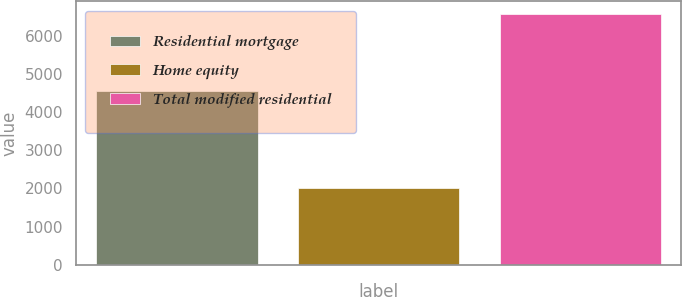Convert chart. <chart><loc_0><loc_0><loc_500><loc_500><bar_chart><fcel>Residential mortgage<fcel>Home equity<fcel>Total modified residential<nl><fcel>4565<fcel>2012<fcel>6577<nl></chart> 